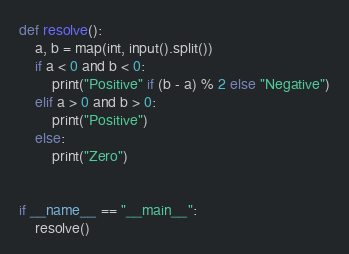<code> <loc_0><loc_0><loc_500><loc_500><_Python_>def resolve():
    a, b = map(int, input().split())
    if a < 0 and b < 0:
        print("Positive" if (b - a) % 2 else "Negative")
    elif a > 0 and b > 0:
        print("Positive")
    else:
        print("Zero")


if __name__ == "__main__":
    resolve()
</code> 